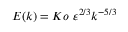Convert formula to latex. <formula><loc_0><loc_0><loc_500><loc_500>E ( k ) = K o \ \varepsilon ^ { 2 / 3 } k ^ { - 5 / 3 }</formula> 